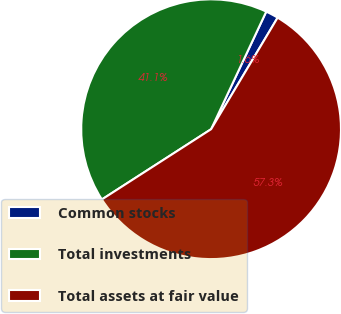<chart> <loc_0><loc_0><loc_500><loc_500><pie_chart><fcel>Common stocks<fcel>Total investments<fcel>Total assets at fair value<nl><fcel>1.58%<fcel>41.08%<fcel>57.35%<nl></chart> 